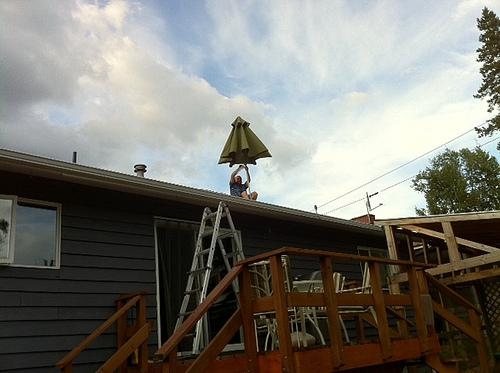Question: what is on the porch?
Choices:
A. Plants.
B. Chairs.
C. Barbecue.
D. Tables and chairs.
Answer with the letter. Answer: B Question: how did the man get on the roof?
Choices:
A. Through the chimney.
B. Elevator.
C. Climbed on a car.
D. A ladder.
Answer with the letter. Answer: D Question: who is on the roof?
Choices:
A. A man.
B. Two men.
C. Three men.
D. Two women.
Answer with the letter. Answer: A Question: how is the man on the roof?
Choices:
A. Sitting.
B. Standing.
C. Bent over.
D. Kneeling.
Answer with the letter. Answer: A Question: why is the man on the roof?
Choices:
A. To open an umbrella.
B. To replace shingles.
C. To look at the view.
D. To retrieve a ball.
Answer with the letter. Answer: A 